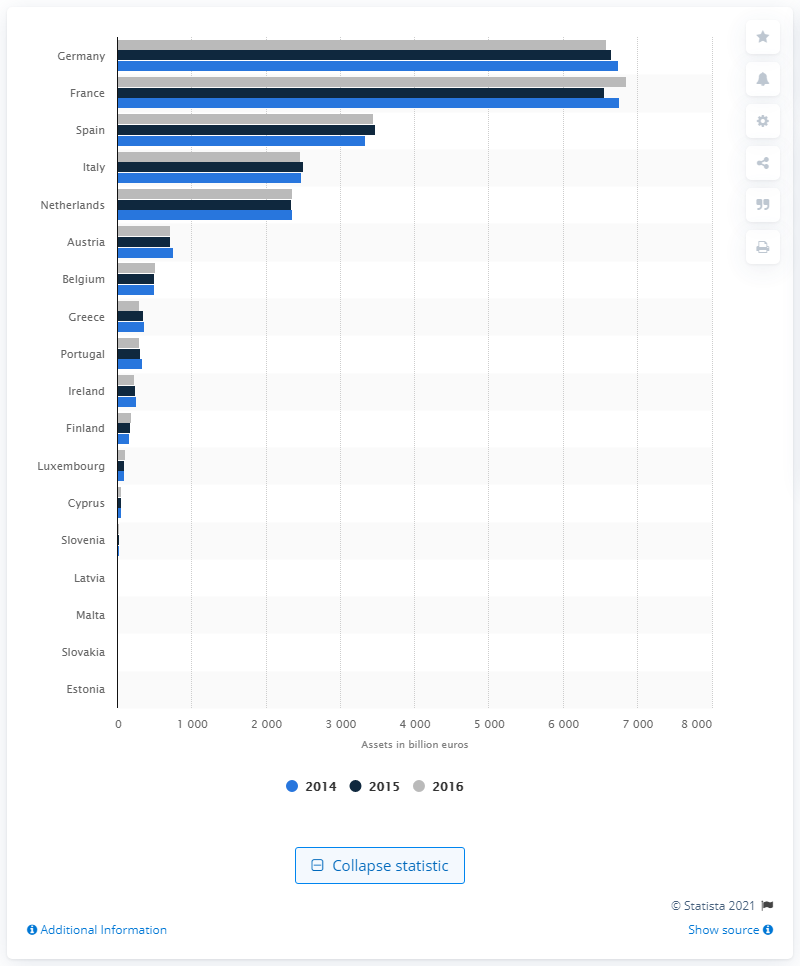List a handful of essential elements in this visual. According to data from 2016, Germany held the highest assets among all countries. In 2016, France had the highest assets among all countries. 